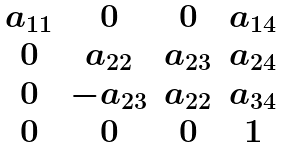<formula> <loc_0><loc_0><loc_500><loc_500>\begin{matrix} a _ { 1 1 } & 0 & 0 & a _ { 1 4 } \\ 0 & a _ { 2 2 } & a _ { 2 3 } & a _ { 2 4 } \\ 0 & - a _ { 2 3 } & a _ { 2 2 } & a _ { 3 4 } \\ 0 & 0 & 0 & 1 \\ \end{matrix}</formula> 